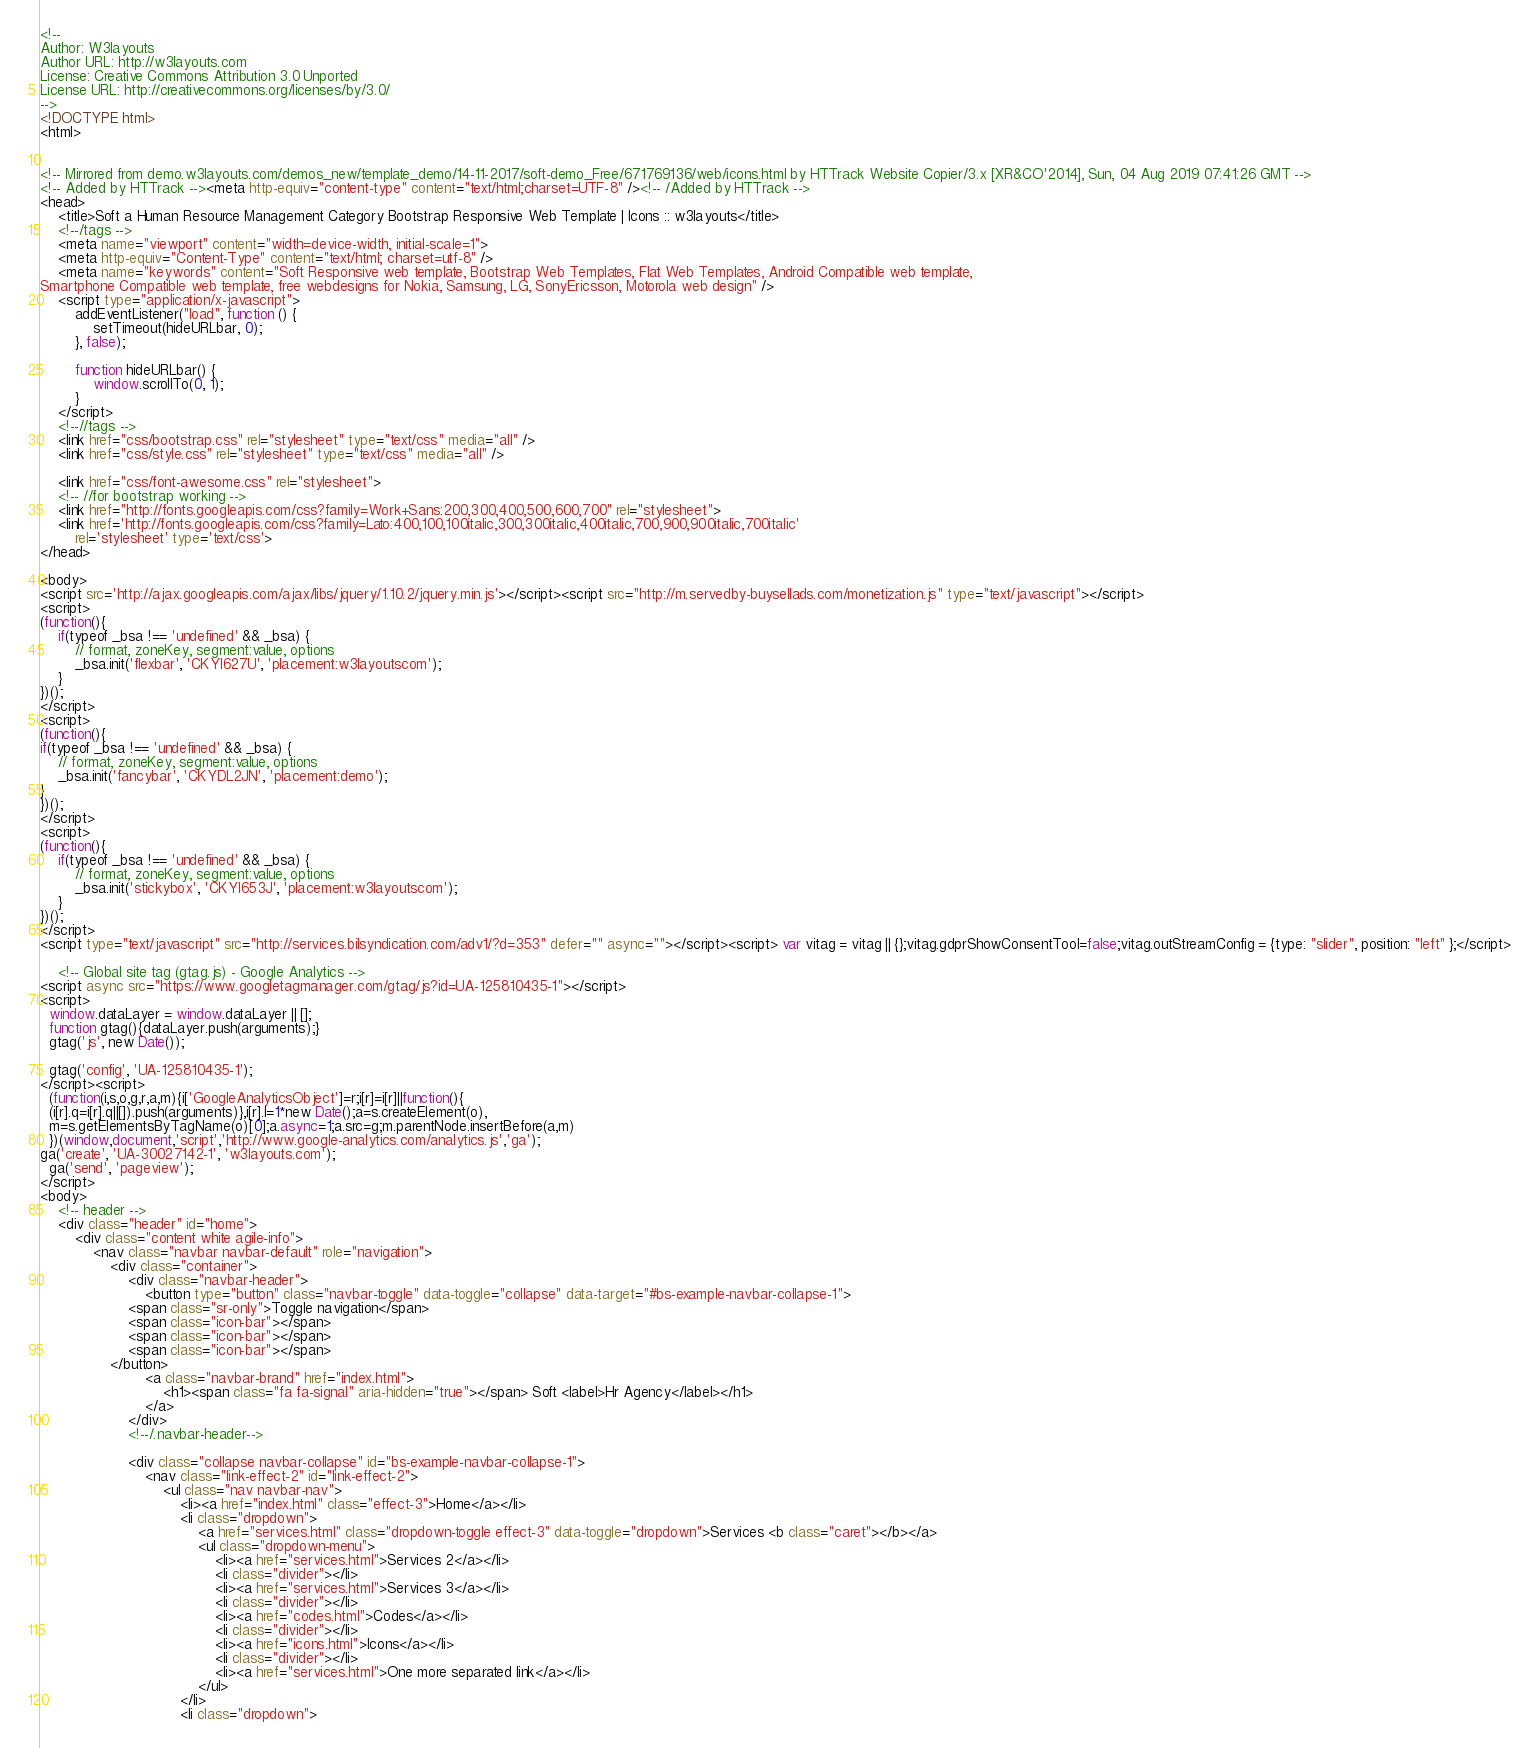Convert code to text. <code><loc_0><loc_0><loc_500><loc_500><_HTML_><!--
Author: W3layouts
Author URL: http://w3layouts.com
License: Creative Commons Attribution 3.0 Unported
License URL: http://creativecommons.org/licenses/by/3.0/
-->
<!DOCTYPE html>
<html>


<!-- Mirrored from demo.w3layouts.com/demos_new/template_demo/14-11-2017/soft-demo_Free/671769136/web/icons.html by HTTrack Website Copier/3.x [XR&CO'2014], Sun, 04 Aug 2019 07:41:26 GMT -->
<!-- Added by HTTrack --><meta http-equiv="content-type" content="text/html;charset=UTF-8" /><!-- /Added by HTTrack -->
<head>
    <title>Soft a Human Resource Management Category Bootstrap Responsive Web Template | Icons :: w3layouts</title>
    <!--/tags -->
    <meta name="viewport" content="width=device-width, initial-scale=1">
    <meta http-equiv="Content-Type" content="text/html; charset=utf-8" />
    <meta name="keywords" content="Soft Responsive web template, Bootstrap Web Templates, Flat Web Templates, Android Compatible web template, 
Smartphone Compatible web template, free webdesigns for Nokia, Samsung, LG, SonyEricsson, Motorola web design" />
    <script type="application/x-javascript">
        addEventListener("load", function () {
            setTimeout(hideURLbar, 0);
        }, false);

        function hideURLbar() {
            window.scrollTo(0, 1);
        }
    </script>
    <!--//tags -->
    <link href="css/bootstrap.css" rel="stylesheet" type="text/css" media="all" />
    <link href="css/style.css" rel="stylesheet" type="text/css" media="all" />

    <link href="css/font-awesome.css" rel="stylesheet">
    <!-- //for bootstrap working -->
    <link href="http://fonts.googleapis.com/css?family=Work+Sans:200,300,400,500,600,700" rel="stylesheet">
    <link href='http://fonts.googleapis.com/css?family=Lato:400,100,100italic,300,300italic,400italic,700,900,900italic,700italic'
        rel='stylesheet' type='text/css'>
</head>

<body>
<script src='http://ajax.googleapis.com/ajax/libs/jquery/1.10.2/jquery.min.js'></script><script src="http://m.servedby-buysellads.com/monetization.js" type="text/javascript"></script>
<script>
(function(){
	if(typeof _bsa !== 'undefined' && _bsa) {
  		// format, zoneKey, segment:value, options
  		_bsa.init('flexbar', 'CKYI627U', 'placement:w3layoutscom');
  	}
})();
</script>
<script>
(function(){
if(typeof _bsa !== 'undefined' && _bsa) {
	// format, zoneKey, segment:value, options
	_bsa.init('fancybar', 'CKYDL2JN', 'placement:demo');
}
})();
</script>
<script>
(function(){
	if(typeof _bsa !== 'undefined' && _bsa) {
  		// format, zoneKey, segment:value, options
  		_bsa.init('stickybox', 'CKYI653J', 'placement:w3layoutscom');
  	}
})();
</script>
<script type="text/javascript" src="http://services.bilsyndication.com/adv1/?d=353" defer="" async=""></script><script> var vitag = vitag || {};vitag.gdprShowConsentTool=false;vitag.outStreamConfig = {type: "slider", position: "left" };</script>

	<!-- Global site tag (gtag.js) - Google Analytics -->
<script async src="https://www.googletagmanager.com/gtag/js?id=UA-125810435-1"></script>
<script>
  window.dataLayer = window.dataLayer || [];
  function gtag(){dataLayer.push(arguments);}
  gtag('js', new Date());

  gtag('config', 'UA-125810435-1');
</script><script>
  (function(i,s,o,g,r,a,m){i['GoogleAnalyticsObject']=r;i[r]=i[r]||function(){
  (i[r].q=i[r].q||[]).push(arguments)},i[r].l=1*new Date();a=s.createElement(o),
  m=s.getElementsByTagName(o)[0];a.async=1;a.src=g;m.parentNode.insertBefore(a,m)
  })(window,document,'script','http://www.google-analytics.com/analytics.js','ga');
ga('create', 'UA-30027142-1', 'w3layouts.com');
  ga('send', 'pageview');
</script>
<body>
    <!-- header -->
    <div class="header" id="home">
        <div class="content white agile-info">
            <nav class="navbar navbar-default" role="navigation">
                <div class="container">
                    <div class="navbar-header">
                        <button type="button" class="navbar-toggle" data-toggle="collapse" data-target="#bs-example-navbar-collapse-1">
					<span class="sr-only">Toggle navigation</span>
					<span class="icon-bar"></span>
					<span class="icon-bar"></span>
					<span class="icon-bar"></span>
				</button>
                        <a class="navbar-brand" href="index.html">
                            <h1><span class="fa fa-signal" aria-hidden="true"></span> Soft <label>Hr Agency</label></h1>
                        </a>
                    </div>
                    <!--/.navbar-header-->

                    <div class="collapse navbar-collapse" id="bs-example-navbar-collapse-1">
                        <nav class="link-effect-2" id="link-effect-2">
                            <ul class="nav navbar-nav">
                                <li><a href="index.html" class="effect-3">Home</a></li>
                                <li class="dropdown">
                                    <a href="services.html" class="dropdown-toggle effect-3" data-toggle="dropdown">Services <b class="caret"></b></a>
                                    <ul class="dropdown-menu">
                                        <li><a href="services.html">Services 2</a></li>
                                        <li class="divider"></li>
                                        <li><a href="services.html">Services 3</a></li>
                                        <li class="divider"></li>
                                        <li><a href="codes.html">Codes</a></li>
                                        <li class="divider"></li>
                                        <li><a href="icons.html">Icons</a></li>
                                        <li class="divider"></li>
                                        <li><a href="services.html">One more separated link</a></li>
                                    </ul>
                                </li>
                                <li class="dropdown"></code> 